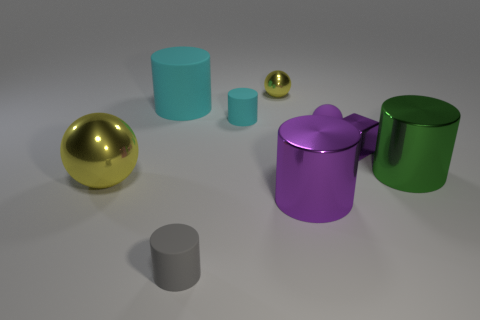Add 1 small yellow spheres. How many objects exist? 10 Subtract all yellow balls. How many balls are left? 1 Subtract all purple balls. How many balls are left? 2 Subtract all cylinders. How many objects are left? 4 Subtract 3 balls. How many balls are left? 0 Subtract all purple shiny cubes. Subtract all cyan things. How many objects are left? 6 Add 5 large balls. How many large balls are left? 6 Add 4 large metallic cylinders. How many large metallic cylinders exist? 6 Subtract 0 yellow cylinders. How many objects are left? 9 Subtract all yellow blocks. Subtract all yellow spheres. How many blocks are left? 1 